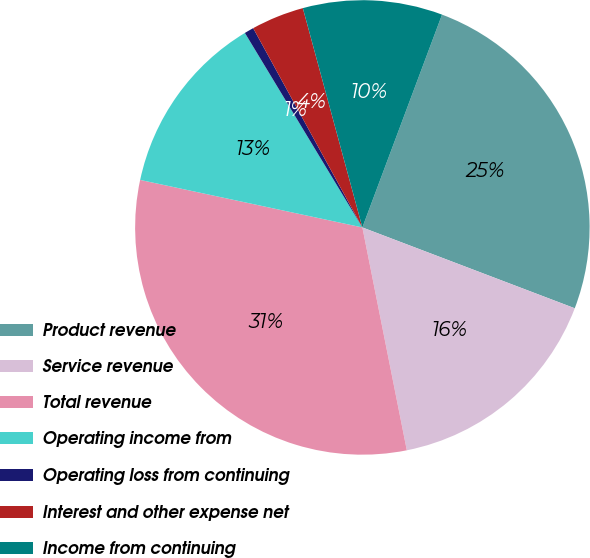Convert chart to OTSL. <chart><loc_0><loc_0><loc_500><loc_500><pie_chart><fcel>Product revenue<fcel>Service revenue<fcel>Total revenue<fcel>Operating income from<fcel>Operating loss from continuing<fcel>Interest and other expense net<fcel>Income from continuing<nl><fcel>25.09%<fcel>16.08%<fcel>31.49%<fcel>13.0%<fcel>0.67%<fcel>3.76%<fcel>9.92%<nl></chart> 